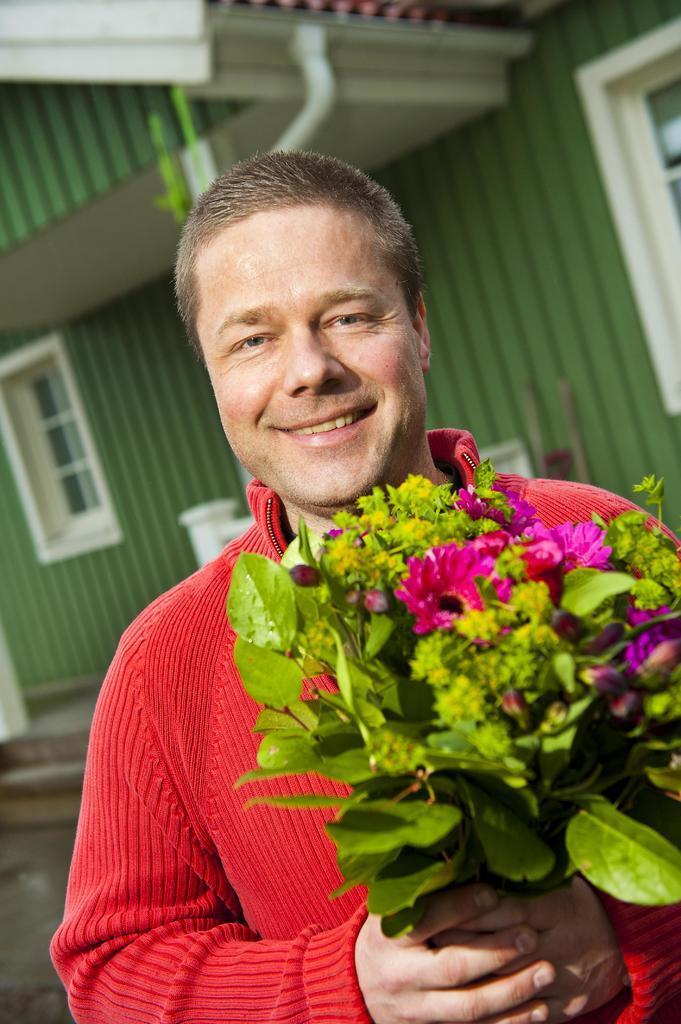Could you give a brief overview of what you see in this image? In this image we can see a person wearing red color dress holding flower bouquet in his hands and there are some flowers which are in pink and yellow color and there are some leaves which are green in color and in the background of the image there is a house which is in green color. 